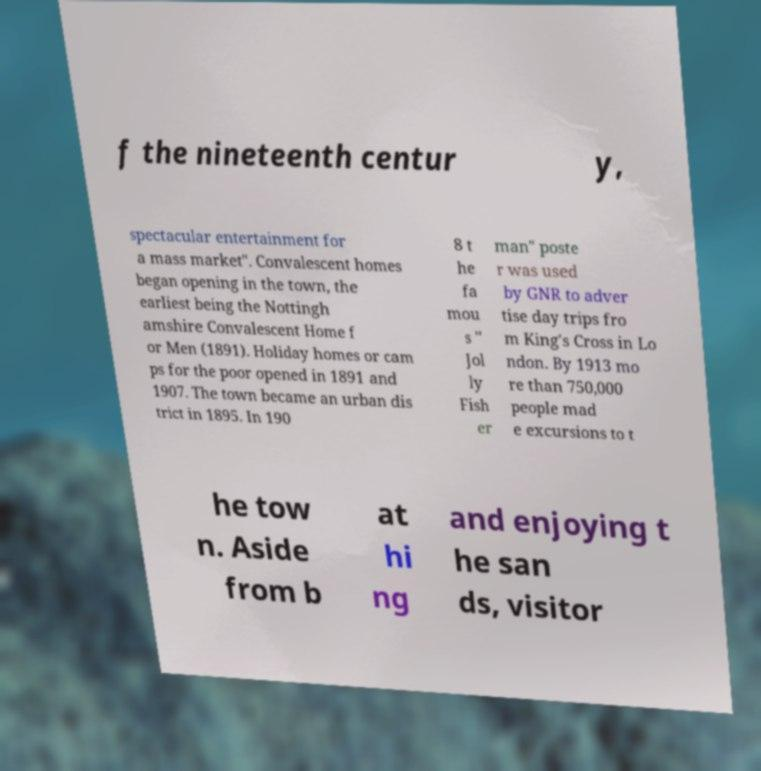I need the written content from this picture converted into text. Can you do that? f the nineteenth centur y, spectacular entertainment for a mass market". Convalescent homes began opening in the town, the earliest being the Nottingh amshire Convalescent Home f or Men (1891). Holiday homes or cam ps for the poor opened in 1891 and 1907. The town became an urban dis trict in 1895. In 190 8 t he fa mou s " Jol ly Fish er man" poste r was used by GNR to adver tise day trips fro m King's Cross in Lo ndon. By 1913 mo re than 750,000 people mad e excursions to t he tow n. Aside from b at hi ng and enjoying t he san ds, visitor 